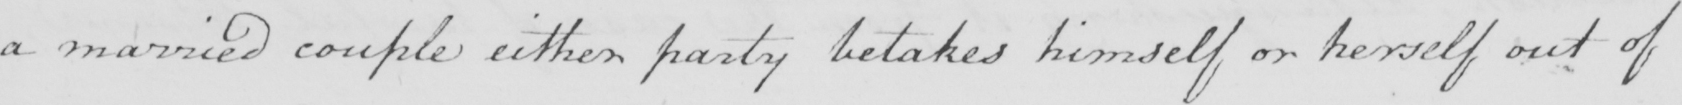What is written in this line of handwriting? a married couple either party betakes himself or herself out of 